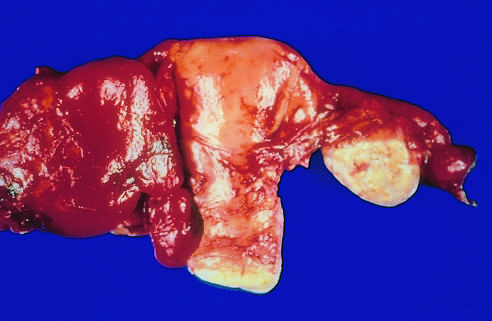what is the tube adherent to?
Answer the question using a single word or phrase. The adjacent ovary on the other side 